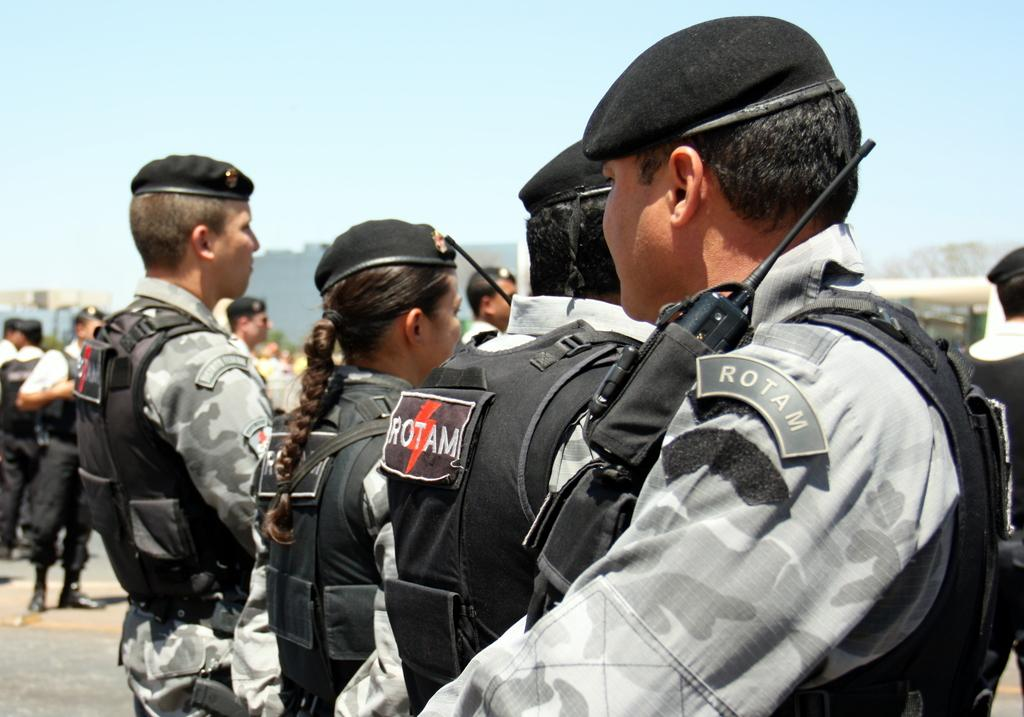What is happening in the center of the image? There are persons standing on the road in the center of the image. Can you describe the background of the image? There are persons, trees, at least one building, a hill, and the sky visible in the background of the image. How many groups of people can be seen in the image? There are two groups of people visible in the image: the persons standing on the road and the persons in the background. What type of alarm can be heard going off in the image? There is no alarm present in the image, and therefore no sound can be heard. 